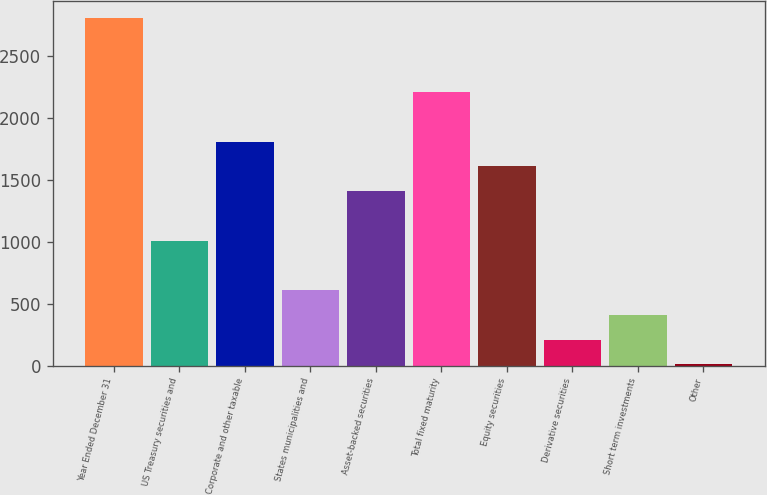Convert chart to OTSL. <chart><loc_0><loc_0><loc_500><loc_500><bar_chart><fcel>Year Ended December 31<fcel>US Treasury securities and<fcel>Corporate and other taxable<fcel>States municipalities and<fcel>Asset-backed securities<fcel>Total fixed maturity<fcel>Equity securities<fcel>Derivative securities<fcel>Short term investments<fcel>Other<nl><fcel>2807.6<fcel>1008.5<fcel>1808.1<fcel>608.7<fcel>1408.3<fcel>2207.9<fcel>1608.2<fcel>208.9<fcel>408.8<fcel>9<nl></chart> 